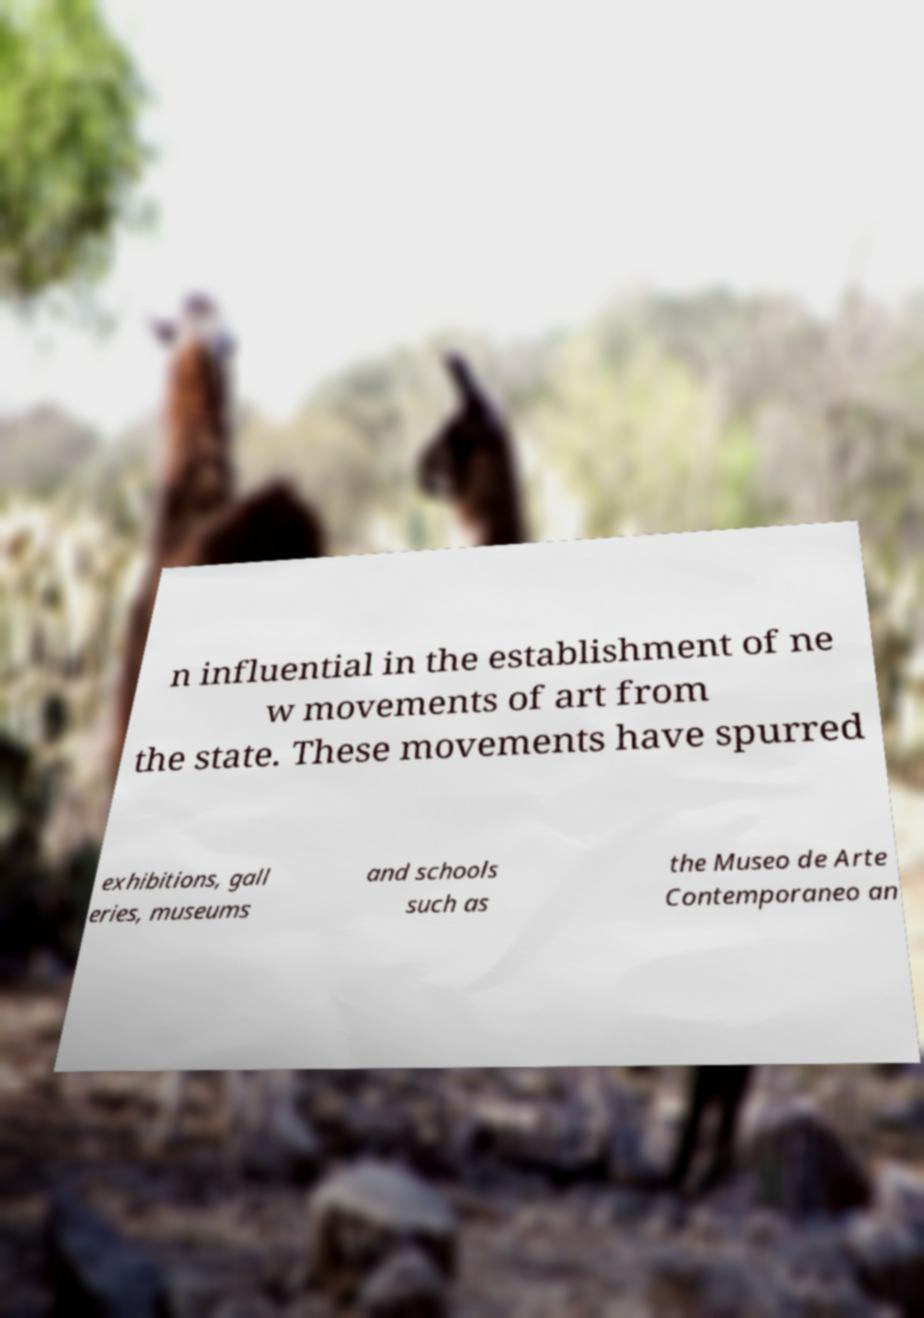Please read and relay the text visible in this image. What does it say? n influential in the establishment of ne w movements of art from the state. These movements have spurred exhibitions, gall eries, museums and schools such as the Museo de Arte Contemporaneo an 